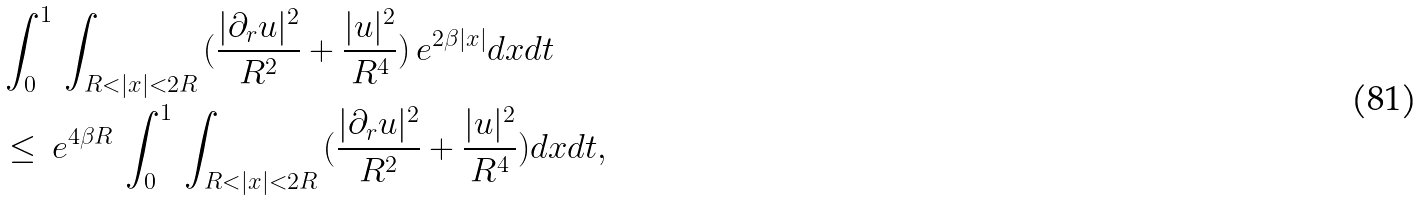Convert formula to latex. <formula><loc_0><loc_0><loc_500><loc_500>& \int _ { 0 } ^ { 1 } \, \int _ { R < | x | < 2 R } \, ( \frac { | \partial _ { r } u | ^ { 2 } } { R ^ { 2 } } + \frac { | u | ^ { 2 } } { R ^ { 4 } } ) \, e ^ { 2 \beta | x | } d x d t \\ & \leq \, e ^ { 4 \beta R } \, \int _ { 0 } ^ { 1 } \, \int _ { R < | x | < 2 R } \, ( \frac { | \partial _ { r } u | ^ { 2 } } { R ^ { 2 } } + \frac { | u | ^ { 2 } } { R ^ { 4 } } ) d x d t ,</formula> 